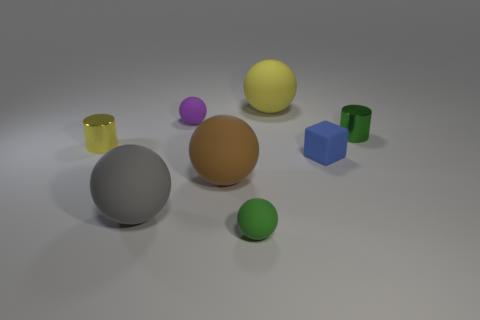Is the number of matte things that are in front of the purple ball less than the number of balls?
Provide a short and direct response. Yes. There is a tiny block that is the same material as the big brown object; what color is it?
Make the answer very short. Blue. There is a yellow thing to the right of the brown rubber sphere; what is its size?
Make the answer very short. Large. Is the blue thing made of the same material as the small green cylinder?
Your response must be concise. No. There is a cylinder behind the metal object to the left of the yellow rubber object; is there a large rubber sphere that is behind it?
Keep it short and to the point. Yes. The cube has what color?
Provide a succinct answer. Blue. The rubber block that is the same size as the green cylinder is what color?
Offer a terse response. Blue. Does the tiny metal object to the right of the big yellow object have the same shape as the yellow metal thing?
Your answer should be compact. Yes. What is the color of the small matte thing on the right side of the big sphere behind the small metallic object that is left of the green sphere?
Ensure brevity in your answer.  Blue. Is there a blue metallic cylinder?
Your answer should be compact. No. 